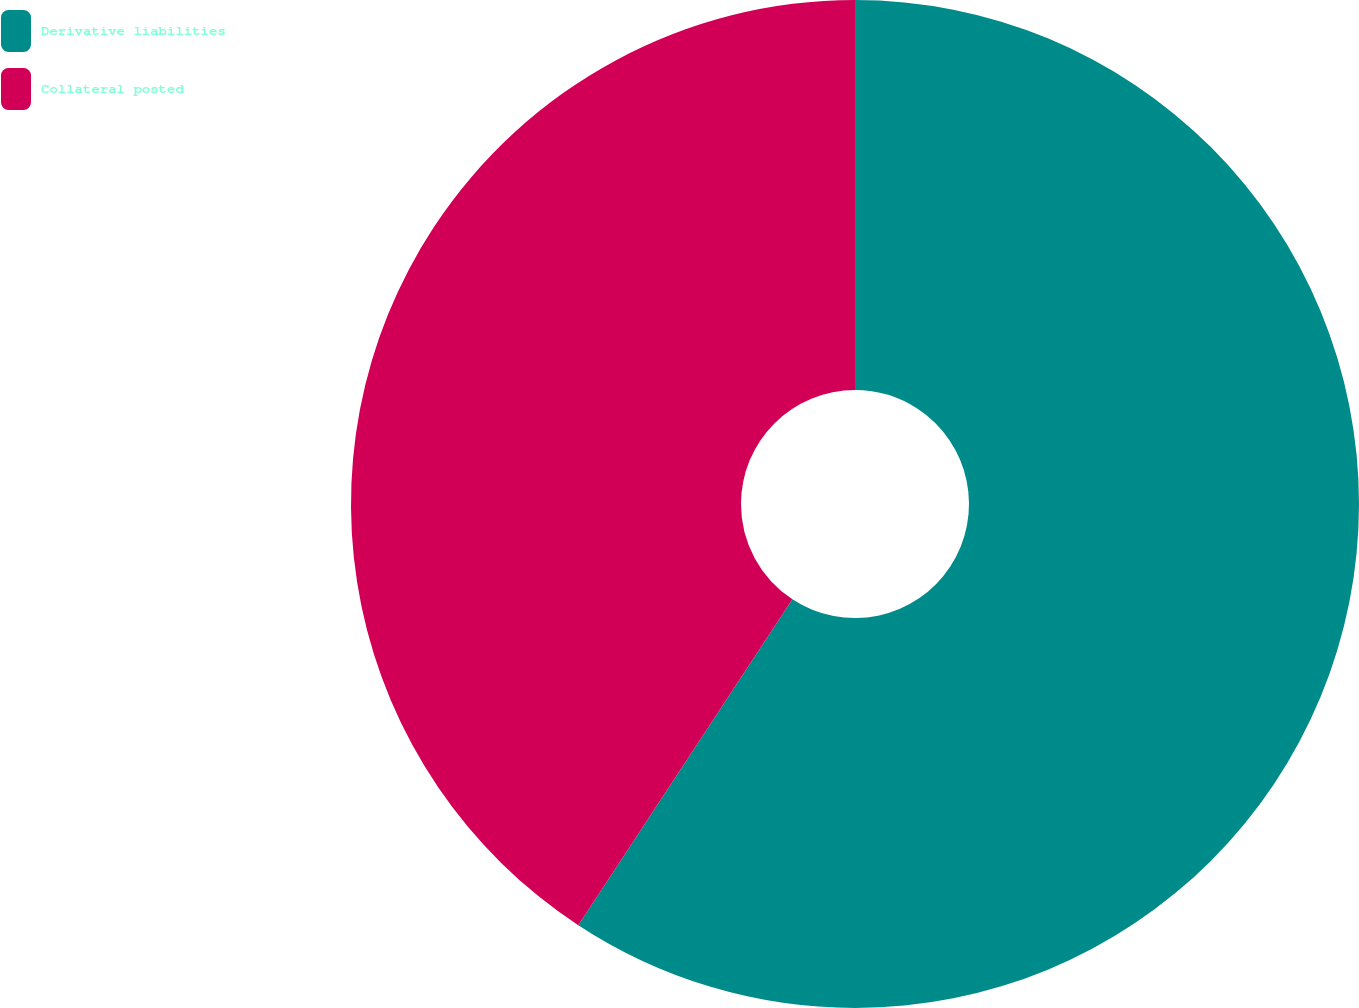Convert chart. <chart><loc_0><loc_0><loc_500><loc_500><pie_chart><fcel>Derivative liabilities<fcel>Collateral posted<nl><fcel>59.25%<fcel>40.75%<nl></chart> 